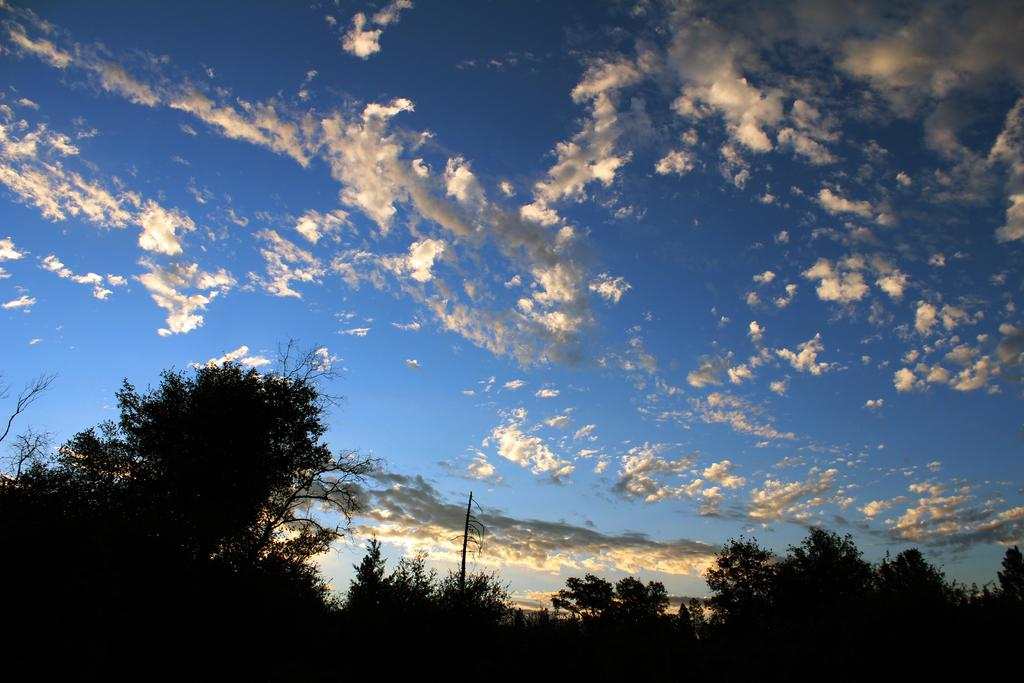What type of vegetation can be seen in the background of the image? There are trees in the background of the image. What other object can be seen in the background of the image? There is a pole in the background of the image. What is visible in the background of the image besides trees and a pole? The sky is visible in the background of the image. Where is the sign located in the image? There is no sign present in the image. What type of balls can be seen in the image? There are no balls present in the image. Is there a dock visible in the image? There is no dock present in the image. 